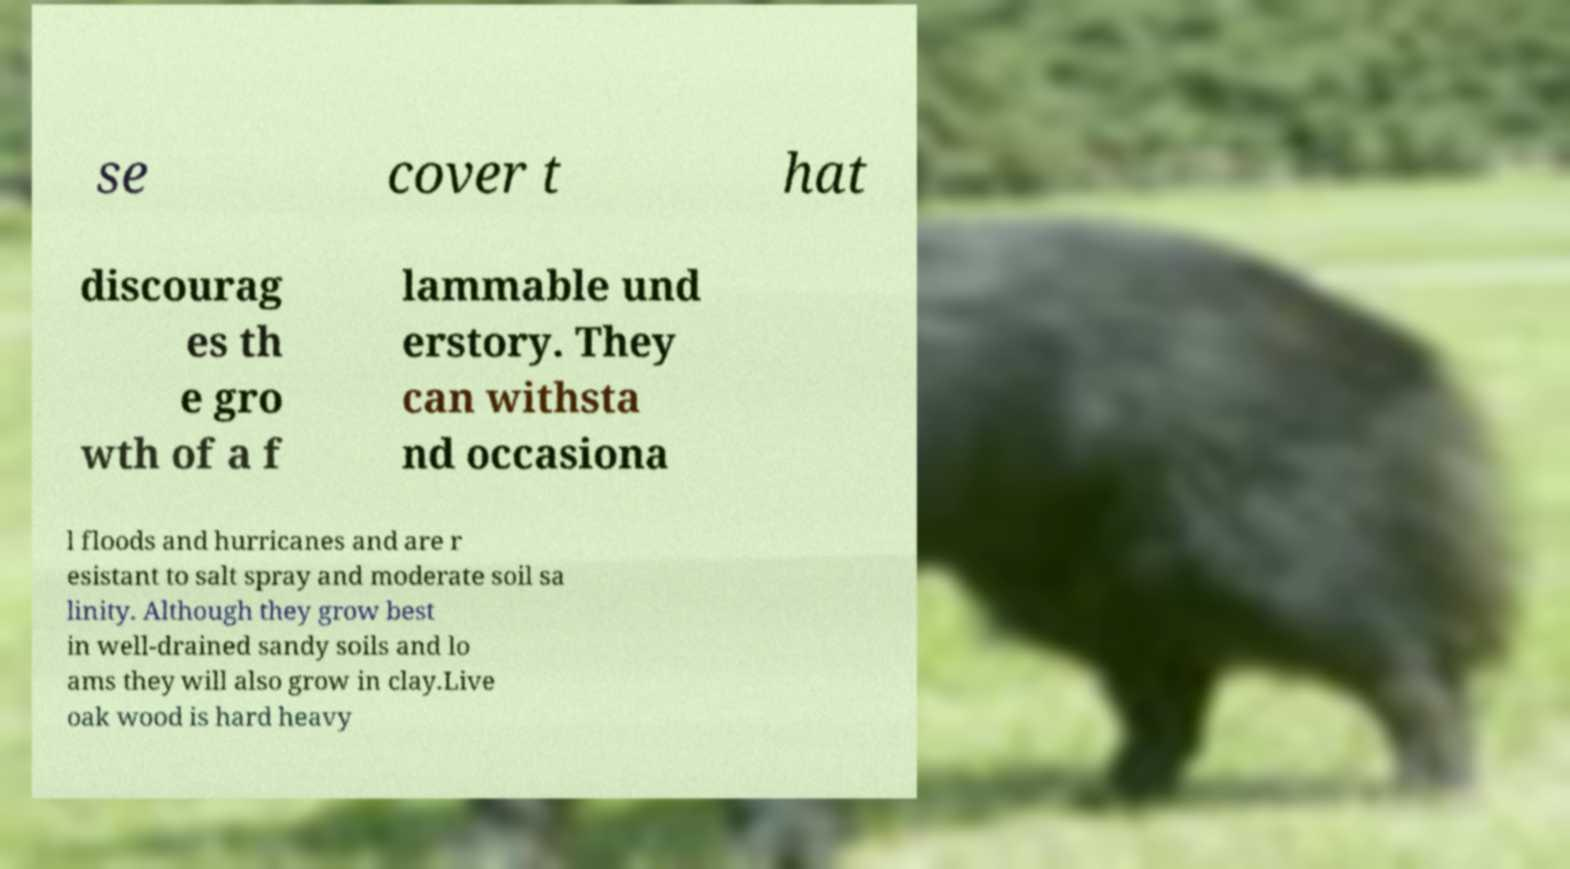There's text embedded in this image that I need extracted. Can you transcribe it verbatim? se cover t hat discourag es th e gro wth of a f lammable und erstory. They can withsta nd occasiona l floods and hurricanes and are r esistant to salt spray and moderate soil sa linity. Although they grow best in well-drained sandy soils and lo ams they will also grow in clay.Live oak wood is hard heavy 